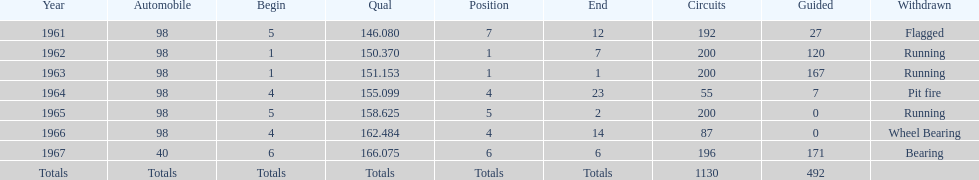What is the difference between the qualfying time in 1967 and 1965? 7.45. 